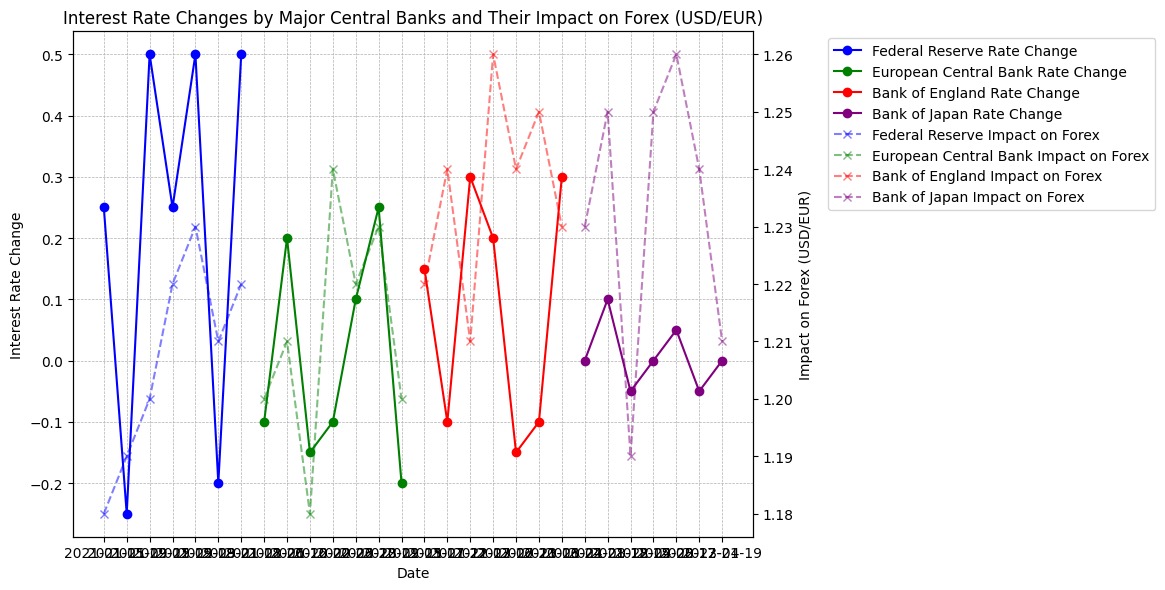Which central bank had the highest interest rate change in 2022 and what was the corresponding impact on forex (USD/EUR)? Federal Reserve's interest rate change was the highest in 2022 with a value of 0.50 on 2022-05-18, and the corresponding impact on forex was 1.23. To find this, locate the highest peak in the 2022 portion of the interest rate change lines.
Answer: Federal Reserve, 1.23 Which bank had the most noticeable impact on forex in January 2022 and what was the interest rate change? Federal Reserve had a significant impact on forex with a rate of 1.22, corresponding to an interest rate change of 0.25. Look for the sharp change in the forex line for January 2022 and match it with the interest rate change line.
Answer: Federal Reserve, 0.25 Which month in 2021 had the highest forex rate (USD/EUR) and which central bank was responsible for the interest rate change at that time? The highest forex rate in 2021 was in August at 1.25, with the Bank of Japan responsible for a 0.10 interest rate change. Locate the peak of the forex (USD/EUR) in 2021 and find the corresponding date and central bank.
Answer: August, Bank of Japan What was the average interest rate change by the Bank of England in 2022? The interest rate changes by the Bank of England in 2022 were 0.30 (March), -0.15 (July) and -0.10 (November). Calculate the average as (0.30 - 0.15 - 0.10) / 3 = 0.05.
Answer: 0.05 How did the Federal Reserve's interest rate change in September 2021 impact the forex rate (USD/EUR)? In September 2021, the Federal Reserve's interest rate change was 0.50, and it impacted the forex rate (USD/EUR) to a value of 1.20. Look at the data points marked in September 2021 for the Federal Reserve's interest rate and corresponding forex rate.
Answer: 1.20 Which central bank had a zero interest rate change over both years, and in which months did it occur? The Bank of Japan had zero interest rate changes in April 2021 and April 2022. Identify the flat lines that intersect the zero value for the Bank of Japan's interest rates across both years.
Answer: Bank of Japan, April 2021 and April 2022 In which month did the European Central Bank increase the interest rate the most in 2021 and what was the percentage change? In June 2021, the European Central Bank increased the interest rate by 0.20, which was the most significant increase that year. Find the highest positive spike in the interest rate change line for the European Central Bank in 2021.
Answer: June, 0.20 